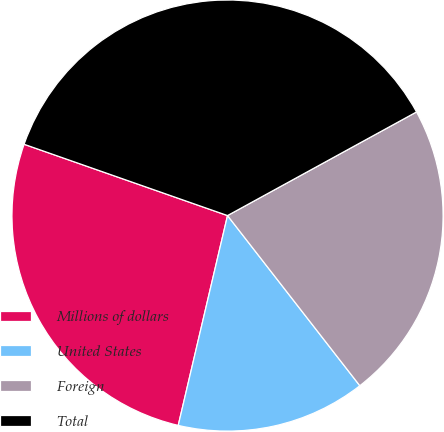Convert chart to OTSL. <chart><loc_0><loc_0><loc_500><loc_500><pie_chart><fcel>Millions of dollars<fcel>United States<fcel>Foreign<fcel>Total<nl><fcel>26.69%<fcel>14.19%<fcel>22.46%<fcel>36.65%<nl></chart> 